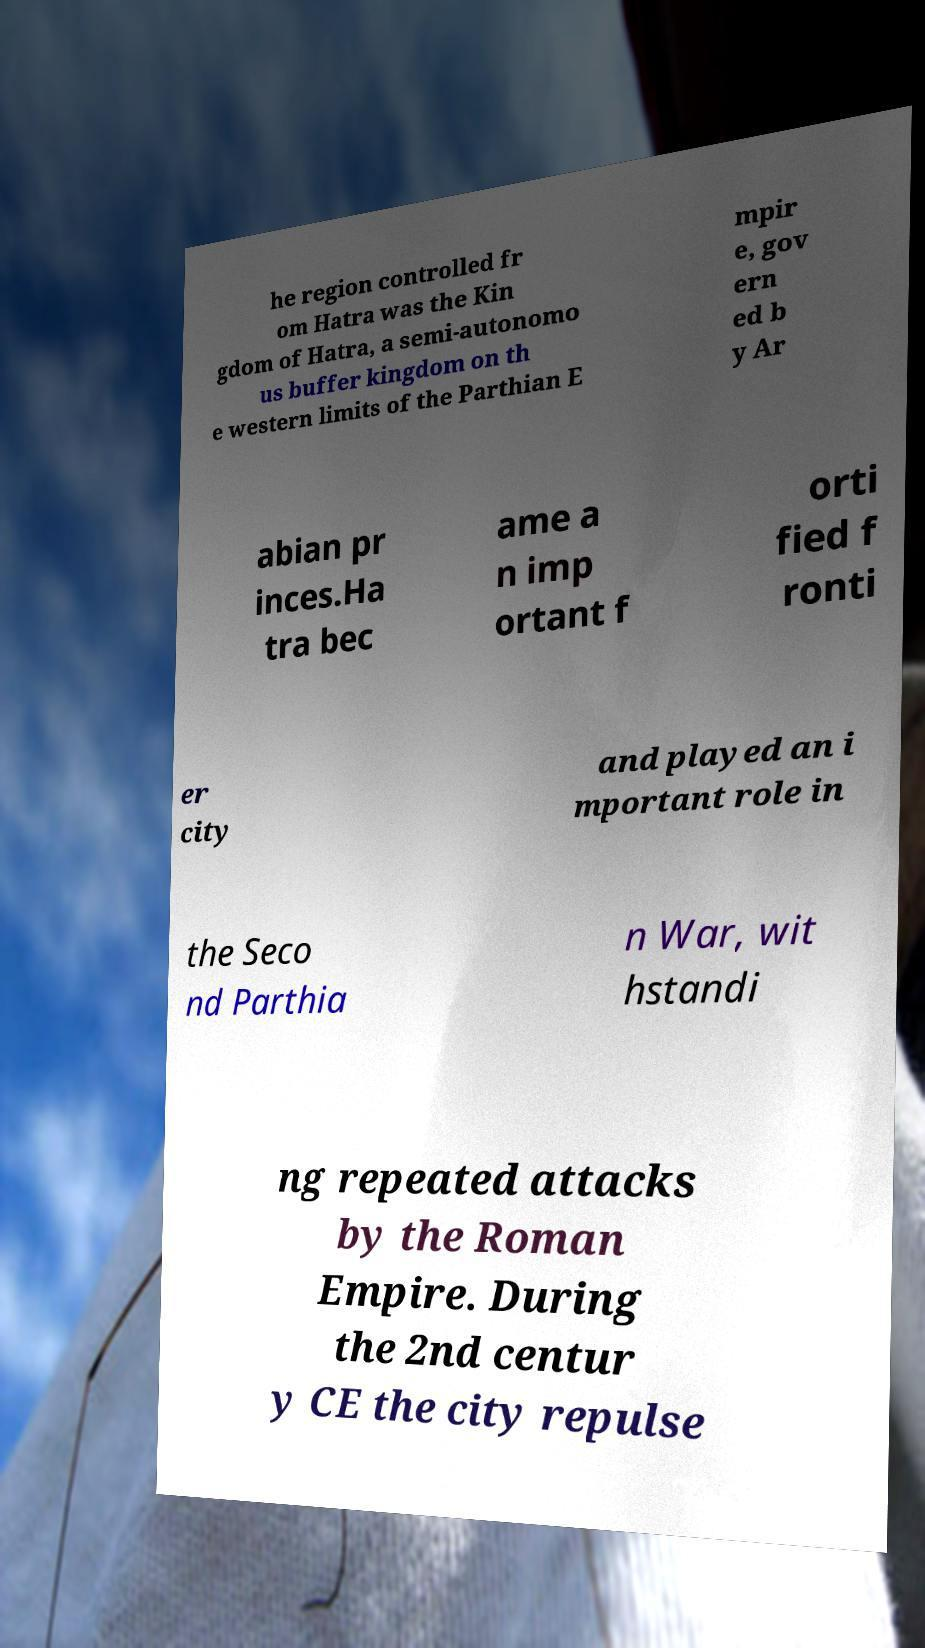For documentation purposes, I need the text within this image transcribed. Could you provide that? he region controlled fr om Hatra was the Kin gdom of Hatra, a semi-autonomo us buffer kingdom on th e western limits of the Parthian E mpir e, gov ern ed b y Ar abian pr inces.Ha tra bec ame a n imp ortant f orti fied f ronti er city and played an i mportant role in the Seco nd Parthia n War, wit hstandi ng repeated attacks by the Roman Empire. During the 2nd centur y CE the city repulse 